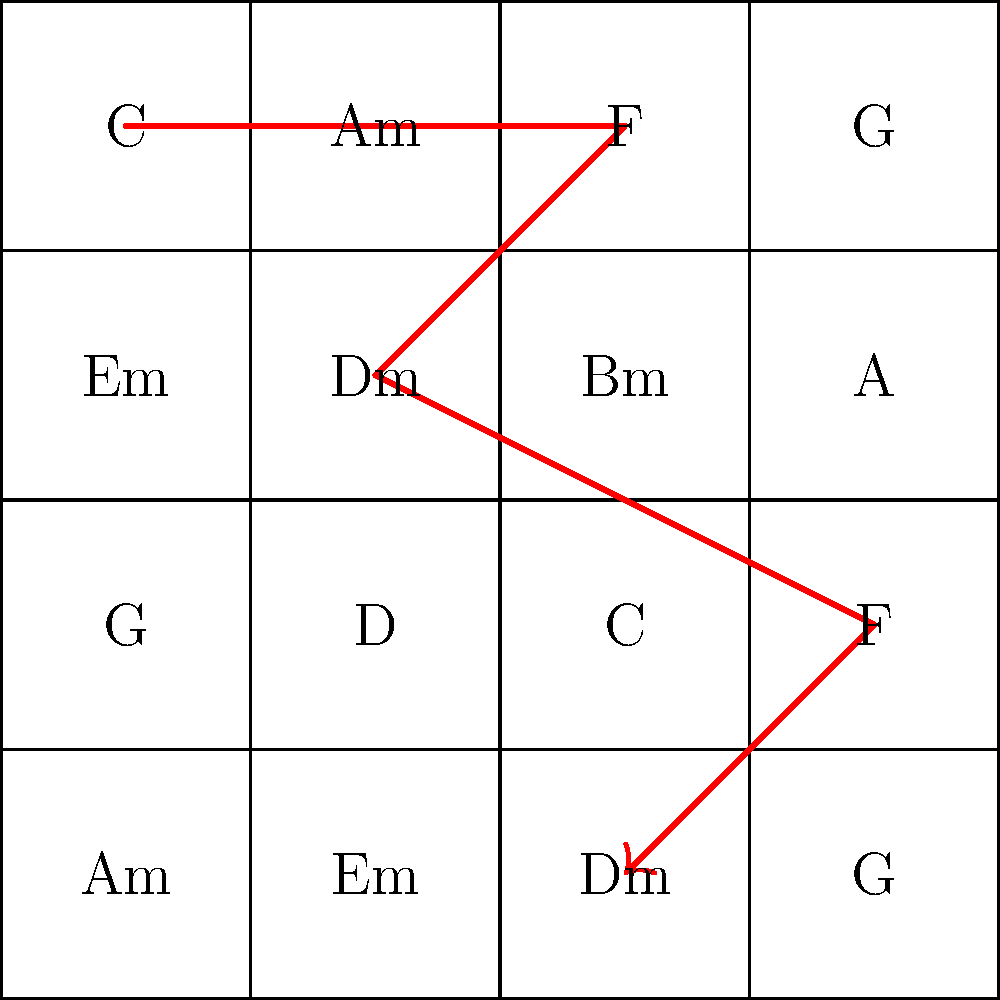Given the chord progression grid above, which represents a maximalist approach to composition, determine the number of unique chords used in the highlighted red path. How does this number relate to the total chord variety in the grid? To solve this problem, we need to follow these steps:

1. Identify the chords in the red path:
   - The path starts at C (0.5, 3.5)
   - Moves to F (2.5, 3.5)
   - Then to Dm (1.5, 2.5)
   - Next to F (3.5, 1.5)
   - Finally to Dm (2.5, 0.5)

2. Count the unique chords in this path:
   C, F, Dm (appears twice)

   Total unique chords: 3

3. Count the total unique chords in the grid:
   C, Am, F, G, Em, Dm, Bm, A, D

   Total unique chords in grid: 9

4. Calculate the ratio:
   $$\frac{\text{Unique chords in path}}{\text{Total unique chords in grid}} = \frac{3}{9} = \frac{1}{3}$$

This ratio demonstrates that the path utilizes one-third of the available chord variety, showcasing a balance between repetition and exploration in the maximalist composition approach.
Answer: 3 unique chords; 1/3 of total variety 